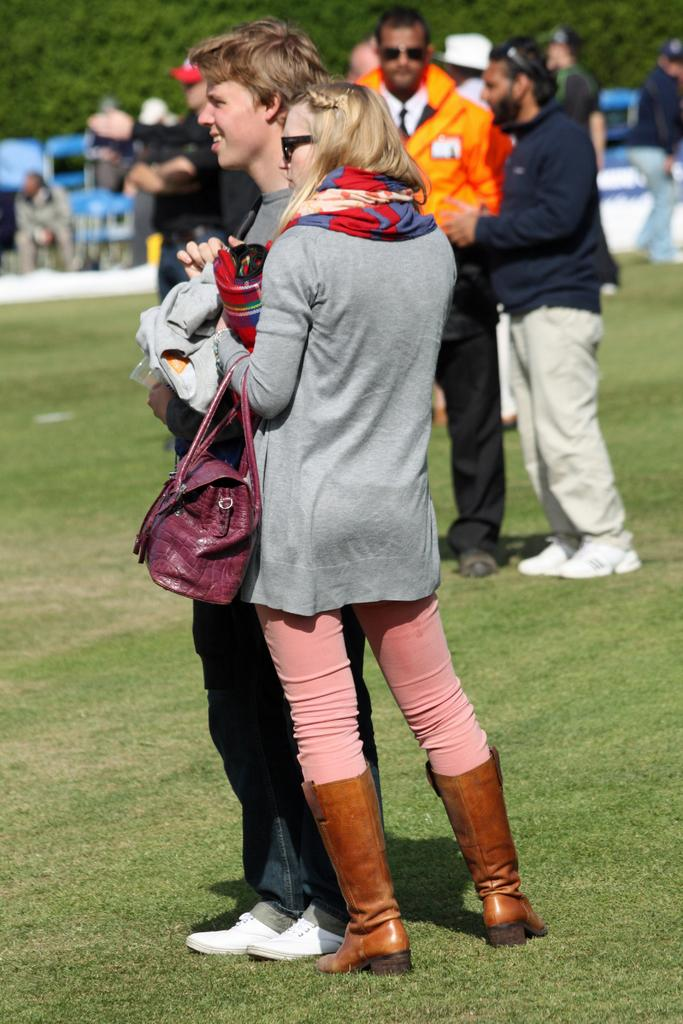What can be seen in the image? There are persons and other objects in the image. Can you describe the persons in the image? There are persons in the image, and some of them can be seen in the background. What is present in the background of the image? In the background, there are chairs and other objects. What is at the bottom of the image? There is grass at the bottom of the image. What direction is the flock of birds flying in the image? There are no birds present in the image, so it is not possible to determine the direction of a flock of birds. 